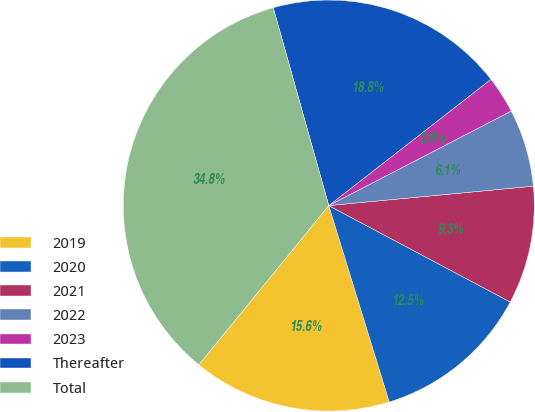Convert chart. <chart><loc_0><loc_0><loc_500><loc_500><pie_chart><fcel>2019<fcel>2020<fcel>2021<fcel>2022<fcel>2023<fcel>Thereafter<fcel>Total<nl><fcel>15.65%<fcel>12.47%<fcel>9.28%<fcel>6.1%<fcel>2.92%<fcel>18.83%<fcel>34.75%<nl></chart> 